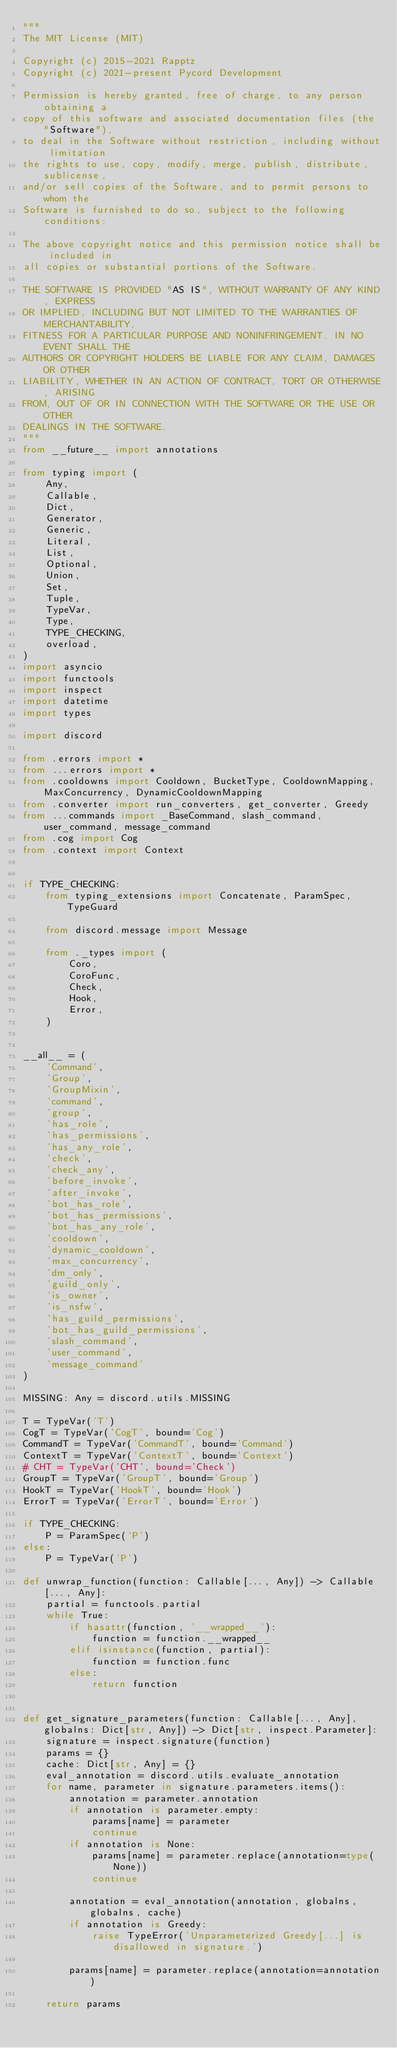<code> <loc_0><loc_0><loc_500><loc_500><_Python_>"""
The MIT License (MIT)

Copyright (c) 2015-2021 Rapptz
Copyright (c) 2021-present Pycord Development

Permission is hereby granted, free of charge, to any person obtaining a
copy of this software and associated documentation files (the "Software"),
to deal in the Software without restriction, including without limitation
the rights to use, copy, modify, merge, publish, distribute, sublicense,
and/or sell copies of the Software, and to permit persons to whom the
Software is furnished to do so, subject to the following conditions:

The above copyright notice and this permission notice shall be included in
all copies or substantial portions of the Software.

THE SOFTWARE IS PROVIDED "AS IS", WITHOUT WARRANTY OF ANY KIND, EXPRESS
OR IMPLIED, INCLUDING BUT NOT LIMITED TO THE WARRANTIES OF MERCHANTABILITY,
FITNESS FOR A PARTICULAR PURPOSE AND NONINFRINGEMENT. IN NO EVENT SHALL THE
AUTHORS OR COPYRIGHT HOLDERS BE LIABLE FOR ANY CLAIM, DAMAGES OR OTHER
LIABILITY, WHETHER IN AN ACTION OF CONTRACT, TORT OR OTHERWISE, ARISING
FROM, OUT OF OR IN CONNECTION WITH THE SOFTWARE OR THE USE OR OTHER
DEALINGS IN THE SOFTWARE.
"""
from __future__ import annotations

from typing import (
    Any,
    Callable,
    Dict,
    Generator,
    Generic,
    Literal,
    List,
    Optional,
    Union,
    Set,
    Tuple,
    TypeVar,
    Type,
    TYPE_CHECKING,
    overload,
)
import asyncio
import functools
import inspect
import datetime
import types

import discord

from .errors import *
from ...errors import *
from .cooldowns import Cooldown, BucketType, CooldownMapping, MaxConcurrency, DynamicCooldownMapping
from .converter import run_converters, get_converter, Greedy
from ...commands import _BaseCommand, slash_command, user_command, message_command
from .cog import Cog
from .context import Context


if TYPE_CHECKING:
    from typing_extensions import Concatenate, ParamSpec, TypeGuard

    from discord.message import Message

    from ._types import (
        Coro,
        CoroFunc,
        Check,
        Hook,
        Error,
    )


__all__ = (
    'Command',
    'Group',
    'GroupMixin',
    'command',
    'group',
    'has_role',
    'has_permissions',
    'has_any_role',
    'check',
    'check_any',
    'before_invoke',
    'after_invoke',
    'bot_has_role',
    'bot_has_permissions',
    'bot_has_any_role',
    'cooldown',
    'dynamic_cooldown',
    'max_concurrency',
    'dm_only',
    'guild_only',
    'is_owner',
    'is_nsfw',
    'has_guild_permissions',
    'bot_has_guild_permissions',
    'slash_command',
    'user_command',
    'message_command'
)

MISSING: Any = discord.utils.MISSING

T = TypeVar('T')
CogT = TypeVar('CogT', bound='Cog')
CommandT = TypeVar('CommandT', bound='Command')
ContextT = TypeVar('ContextT', bound='Context')
# CHT = TypeVar('CHT', bound='Check')
GroupT = TypeVar('GroupT', bound='Group')
HookT = TypeVar('HookT', bound='Hook')
ErrorT = TypeVar('ErrorT', bound='Error')

if TYPE_CHECKING:
    P = ParamSpec('P')
else:
    P = TypeVar('P')

def unwrap_function(function: Callable[..., Any]) -> Callable[..., Any]:
    partial = functools.partial
    while True:
        if hasattr(function, '__wrapped__'):
            function = function.__wrapped__
        elif isinstance(function, partial):
            function = function.func
        else:
            return function


def get_signature_parameters(function: Callable[..., Any], globalns: Dict[str, Any]) -> Dict[str, inspect.Parameter]:
    signature = inspect.signature(function)
    params = {}
    cache: Dict[str, Any] = {}
    eval_annotation = discord.utils.evaluate_annotation
    for name, parameter in signature.parameters.items():
        annotation = parameter.annotation
        if annotation is parameter.empty:
            params[name] = parameter
            continue
        if annotation is None:
            params[name] = parameter.replace(annotation=type(None))
            continue

        annotation = eval_annotation(annotation, globalns, globalns, cache)
        if annotation is Greedy:
            raise TypeError('Unparameterized Greedy[...] is disallowed in signature.')

        params[name] = parameter.replace(annotation=annotation)

    return params

</code> 